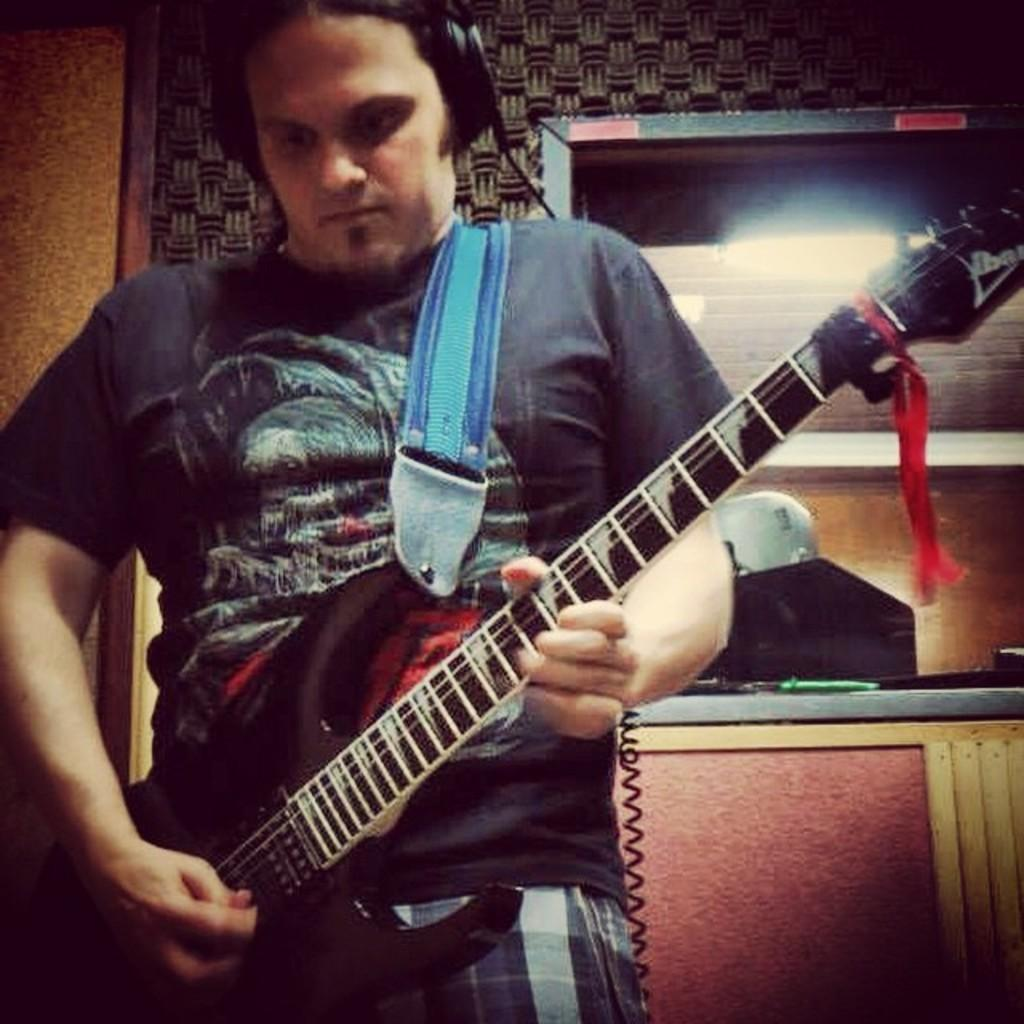What is the main subject of the image? There is a man in the image. What is the man doing in the image? The man is standing in the image. What object is the man holding in the image? The man is holding a guitar in the image. What can be seen in the background of the image? There is a wall in the background of the image. What type of scarf is the man wearing in the image? There is no scarf present in the image; the man is holding a guitar. How does the man's flight to another country appear in the image? There is no flight or reference to a flight in the image; it features a man standing with a guitar. 